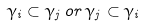Convert formula to latex. <formula><loc_0><loc_0><loc_500><loc_500>\gamma _ { i } \subset \gamma _ { j } \, o r \, \gamma _ { j } \subset \gamma _ { i }</formula> 